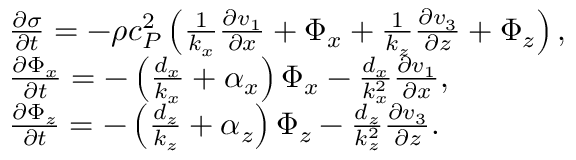<formula> <loc_0><loc_0><loc_500><loc_500>\begin{array} { r l } & { \frac { \partial \sigma } { \partial t } = - \rho c _ { P } ^ { 2 } \left ( \frac { 1 } { k _ { x } } \frac { \partial v _ { 1 } } { \partial x } + \Phi _ { x } + \frac { 1 } { k _ { z } } \frac { \partial v _ { 3 } } { \partial z } + \Phi _ { z } \right ) , } \\ & { \frac { \partial \Phi _ { x } } { \partial t } = - \left ( \frac { d _ { x } } { k _ { x } } + \alpha _ { x } \right ) \Phi _ { x } - \frac { d _ { x } } { k _ { x } ^ { 2 } } \frac { \partial v _ { 1 } } { \partial x } , } \\ & { \frac { \partial \Phi _ { z } } { \partial t } = - \left ( \frac { d _ { z } } { k _ { z } } + \alpha _ { z } \right ) \Phi _ { z } - \frac { d _ { z } } { k _ { z } ^ { 2 } } \frac { \partial v _ { 3 } } { \partial z } . } \end{array}</formula> 